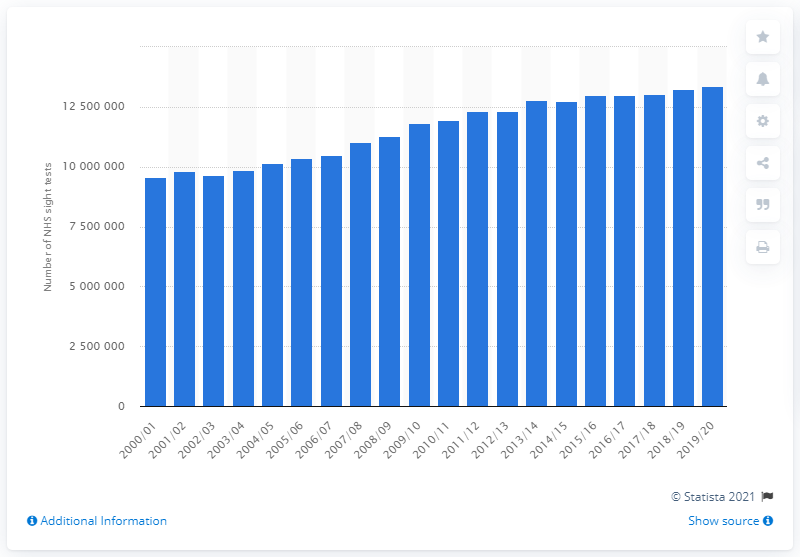Draw attention to some important aspects in this diagram. In the 2019/2020 fiscal year, a total of 1,335,5060 eye examinations were conducted in England. In the year 2000, a total of 9662052 sight tests were conducted by the NHS. 